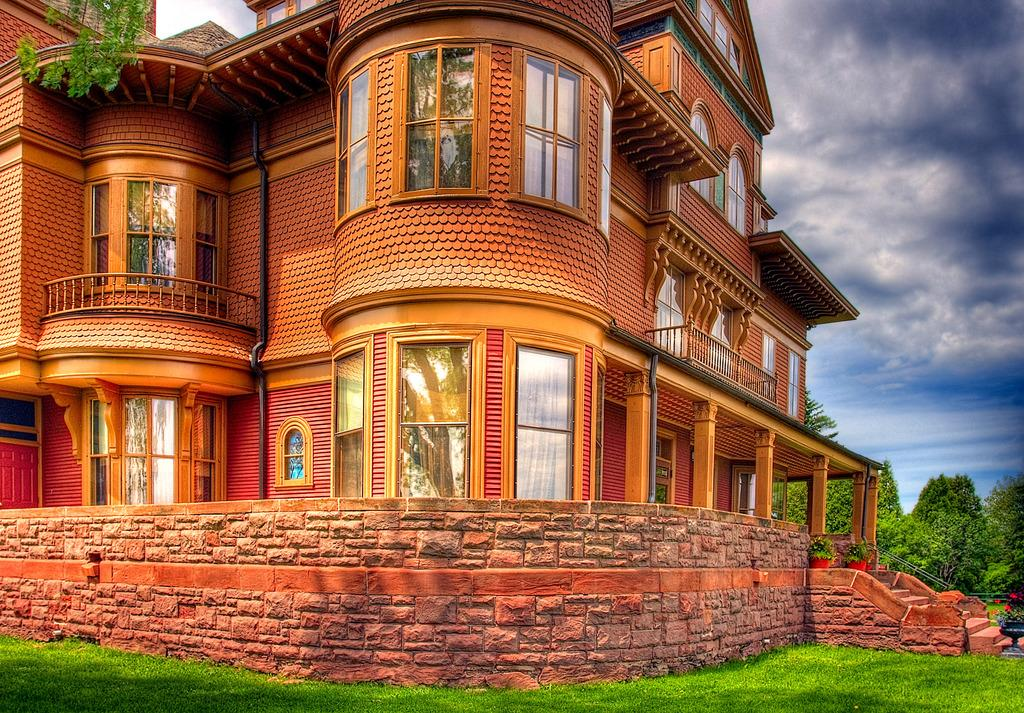What type of structure is present in the image? There is a building in the image. What feature can be seen on the building? The building has windows. What other object is present in the image? There is a wall in the image. What type of vegetation can be seen in the image? There is grass, plants, flowers, and trees in the image. What is visible in the background of the image? The sky is visible in the background of the image. What can be observed in the sky? There are clouds in the sky. How does the wall stretch across the image? The wall does not stretch across the image; it is a stationary object with a fixed size and shape. 